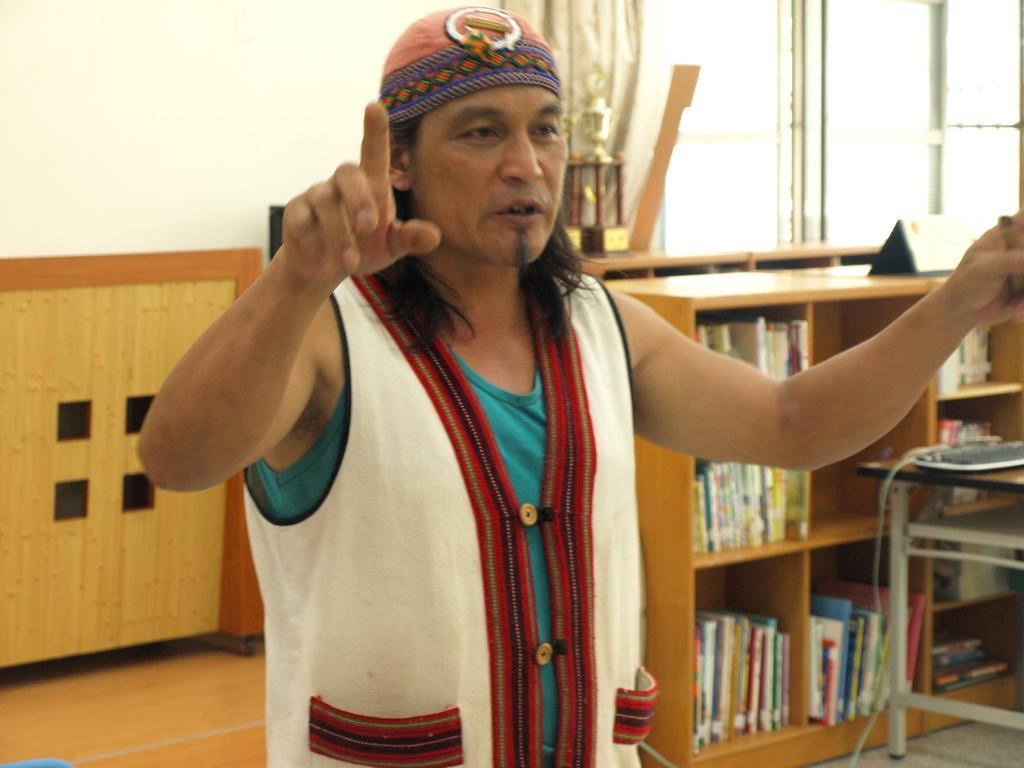Describe this image in one or two sentences. In the middle of the image a man is standing and talking. Behind him there is a table. Bottom right side of the image there is a bookshelf and there is a table on the table there is a keyboard. Top right side of the image there is a glass window. Top left side of the image there is a wall. 